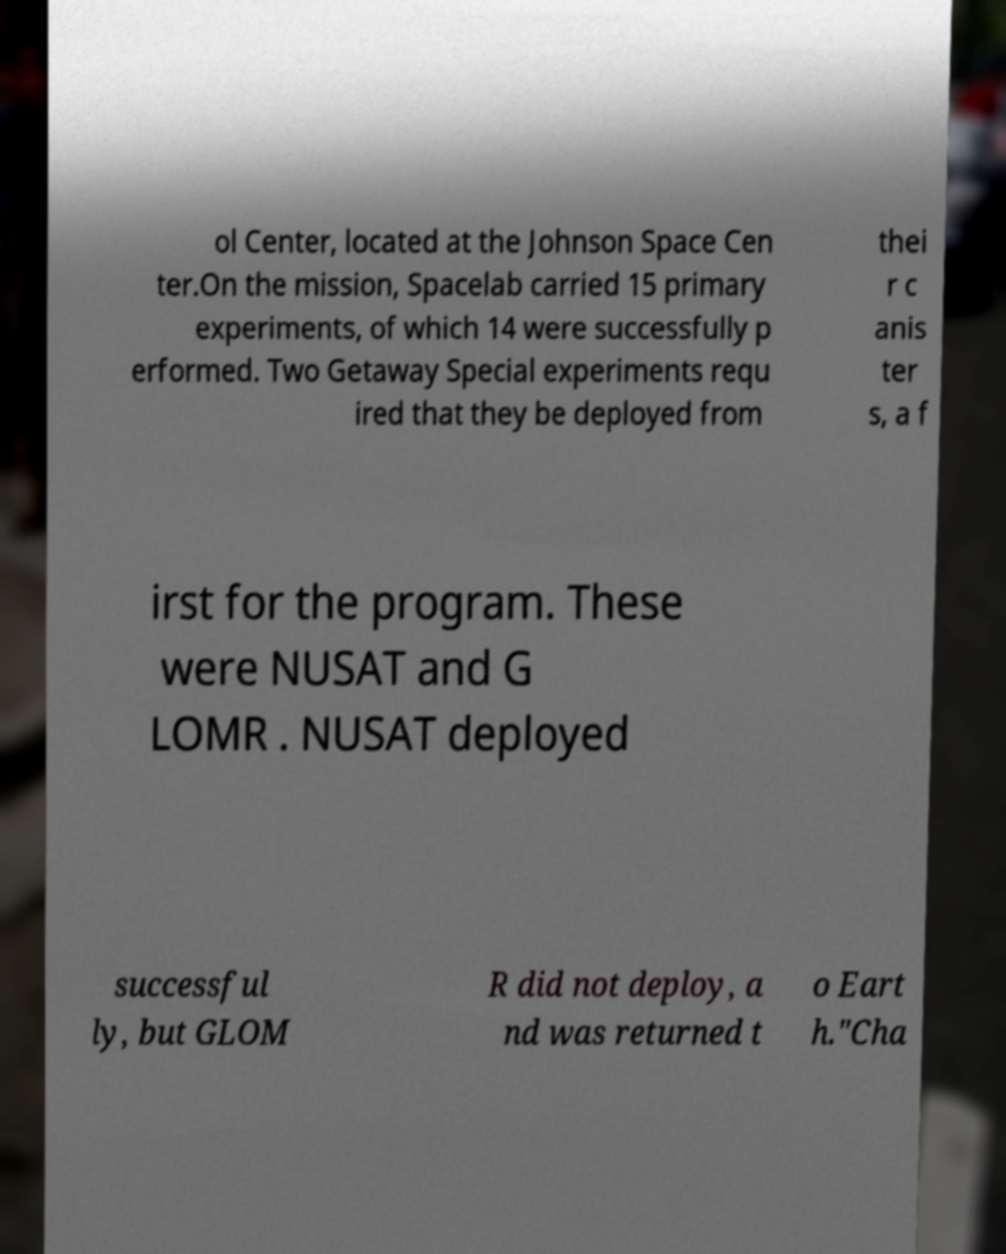For documentation purposes, I need the text within this image transcribed. Could you provide that? ol Center, located at the Johnson Space Cen ter.On the mission, Spacelab carried 15 primary experiments, of which 14 were successfully p erformed. Two Getaway Special experiments requ ired that they be deployed from thei r c anis ter s, a f irst for the program. These were NUSAT and G LOMR . NUSAT deployed successful ly, but GLOM R did not deploy, a nd was returned t o Eart h."Cha 